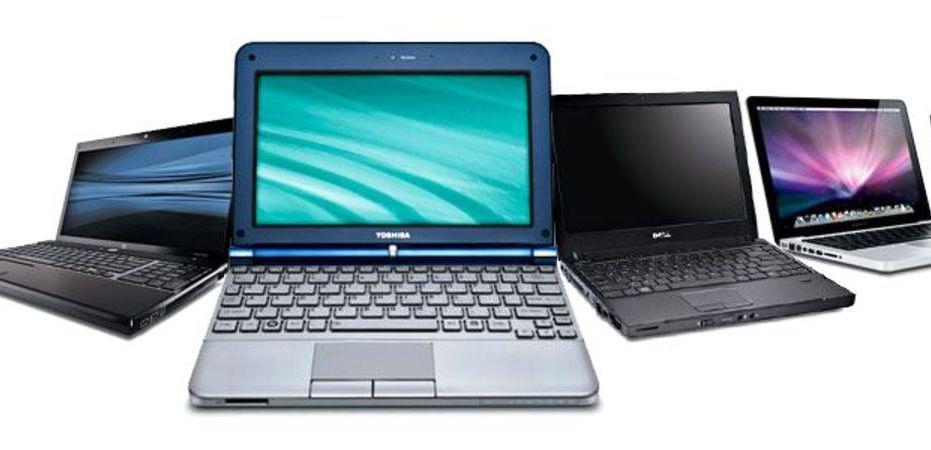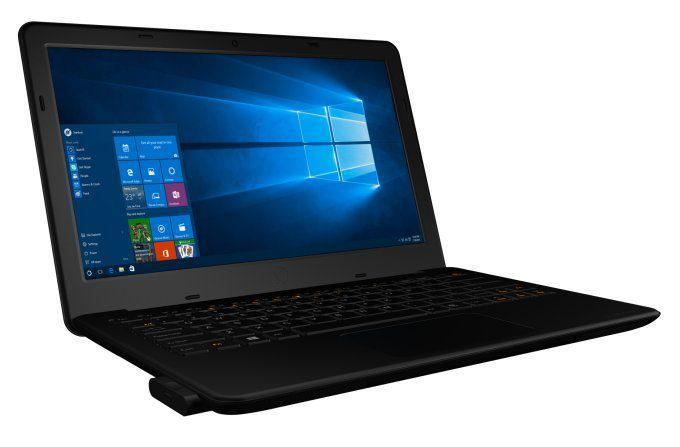The first image is the image on the left, the second image is the image on the right. Considering the images on both sides, is "The left image contains at least two laptop computers." valid? Answer yes or no. Yes. The first image is the image on the left, the second image is the image on the right. Evaluate the accuracy of this statement regarding the images: "One laptop is shown with the monitor and keyboard disconnected from each other.". Is it true? Answer yes or no. No. 